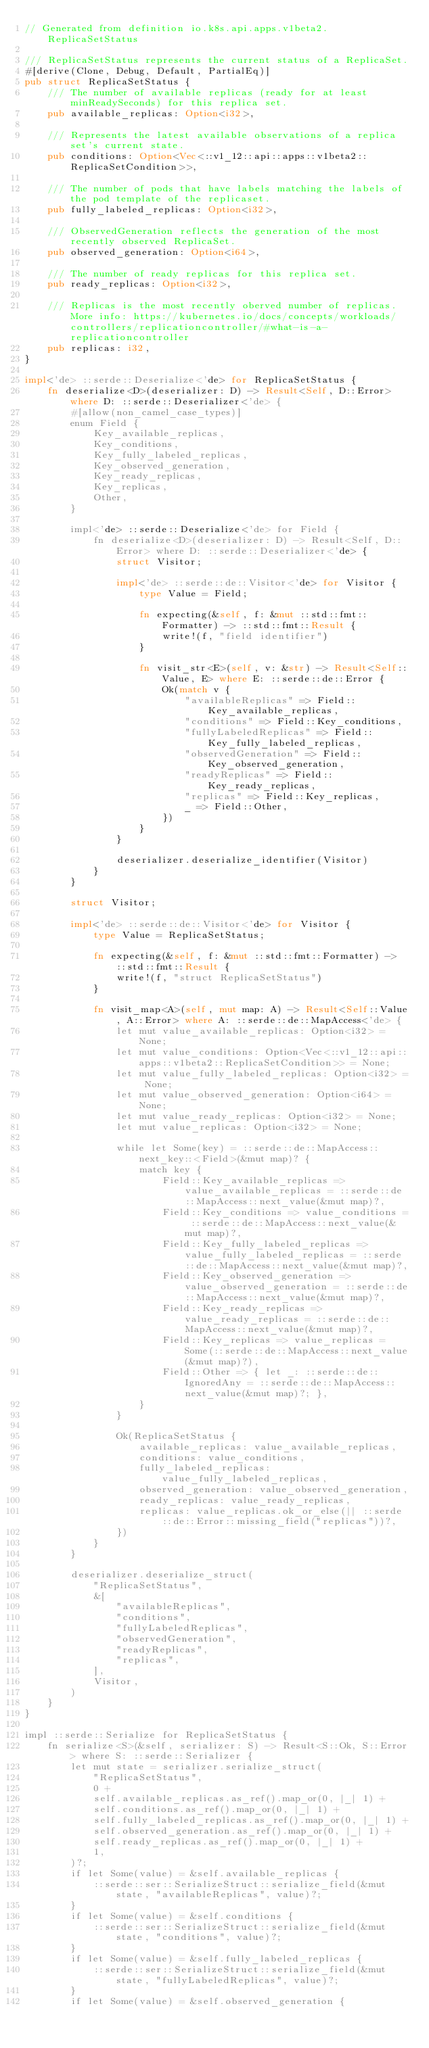Convert code to text. <code><loc_0><loc_0><loc_500><loc_500><_Rust_>// Generated from definition io.k8s.api.apps.v1beta2.ReplicaSetStatus

/// ReplicaSetStatus represents the current status of a ReplicaSet.
#[derive(Clone, Debug, Default, PartialEq)]
pub struct ReplicaSetStatus {
    /// The number of available replicas (ready for at least minReadySeconds) for this replica set.
    pub available_replicas: Option<i32>,

    /// Represents the latest available observations of a replica set's current state.
    pub conditions: Option<Vec<::v1_12::api::apps::v1beta2::ReplicaSetCondition>>,

    /// The number of pods that have labels matching the labels of the pod template of the replicaset.
    pub fully_labeled_replicas: Option<i32>,

    /// ObservedGeneration reflects the generation of the most recently observed ReplicaSet.
    pub observed_generation: Option<i64>,

    /// The number of ready replicas for this replica set.
    pub ready_replicas: Option<i32>,

    /// Replicas is the most recently oberved number of replicas. More info: https://kubernetes.io/docs/concepts/workloads/controllers/replicationcontroller/#what-is-a-replicationcontroller
    pub replicas: i32,
}

impl<'de> ::serde::Deserialize<'de> for ReplicaSetStatus {
    fn deserialize<D>(deserializer: D) -> Result<Self, D::Error> where D: ::serde::Deserializer<'de> {
        #[allow(non_camel_case_types)]
        enum Field {
            Key_available_replicas,
            Key_conditions,
            Key_fully_labeled_replicas,
            Key_observed_generation,
            Key_ready_replicas,
            Key_replicas,
            Other,
        }

        impl<'de> ::serde::Deserialize<'de> for Field {
            fn deserialize<D>(deserializer: D) -> Result<Self, D::Error> where D: ::serde::Deserializer<'de> {
                struct Visitor;

                impl<'de> ::serde::de::Visitor<'de> for Visitor {
                    type Value = Field;

                    fn expecting(&self, f: &mut ::std::fmt::Formatter) -> ::std::fmt::Result {
                        write!(f, "field identifier")
                    }

                    fn visit_str<E>(self, v: &str) -> Result<Self::Value, E> where E: ::serde::de::Error {
                        Ok(match v {
                            "availableReplicas" => Field::Key_available_replicas,
                            "conditions" => Field::Key_conditions,
                            "fullyLabeledReplicas" => Field::Key_fully_labeled_replicas,
                            "observedGeneration" => Field::Key_observed_generation,
                            "readyReplicas" => Field::Key_ready_replicas,
                            "replicas" => Field::Key_replicas,
                            _ => Field::Other,
                        })
                    }
                }

                deserializer.deserialize_identifier(Visitor)
            }
        }

        struct Visitor;

        impl<'de> ::serde::de::Visitor<'de> for Visitor {
            type Value = ReplicaSetStatus;

            fn expecting(&self, f: &mut ::std::fmt::Formatter) -> ::std::fmt::Result {
                write!(f, "struct ReplicaSetStatus")
            }

            fn visit_map<A>(self, mut map: A) -> Result<Self::Value, A::Error> where A: ::serde::de::MapAccess<'de> {
                let mut value_available_replicas: Option<i32> = None;
                let mut value_conditions: Option<Vec<::v1_12::api::apps::v1beta2::ReplicaSetCondition>> = None;
                let mut value_fully_labeled_replicas: Option<i32> = None;
                let mut value_observed_generation: Option<i64> = None;
                let mut value_ready_replicas: Option<i32> = None;
                let mut value_replicas: Option<i32> = None;

                while let Some(key) = ::serde::de::MapAccess::next_key::<Field>(&mut map)? {
                    match key {
                        Field::Key_available_replicas => value_available_replicas = ::serde::de::MapAccess::next_value(&mut map)?,
                        Field::Key_conditions => value_conditions = ::serde::de::MapAccess::next_value(&mut map)?,
                        Field::Key_fully_labeled_replicas => value_fully_labeled_replicas = ::serde::de::MapAccess::next_value(&mut map)?,
                        Field::Key_observed_generation => value_observed_generation = ::serde::de::MapAccess::next_value(&mut map)?,
                        Field::Key_ready_replicas => value_ready_replicas = ::serde::de::MapAccess::next_value(&mut map)?,
                        Field::Key_replicas => value_replicas = Some(::serde::de::MapAccess::next_value(&mut map)?),
                        Field::Other => { let _: ::serde::de::IgnoredAny = ::serde::de::MapAccess::next_value(&mut map)?; },
                    }
                }

                Ok(ReplicaSetStatus {
                    available_replicas: value_available_replicas,
                    conditions: value_conditions,
                    fully_labeled_replicas: value_fully_labeled_replicas,
                    observed_generation: value_observed_generation,
                    ready_replicas: value_ready_replicas,
                    replicas: value_replicas.ok_or_else(|| ::serde::de::Error::missing_field("replicas"))?,
                })
            }
        }

        deserializer.deserialize_struct(
            "ReplicaSetStatus",
            &[
                "availableReplicas",
                "conditions",
                "fullyLabeledReplicas",
                "observedGeneration",
                "readyReplicas",
                "replicas",
            ],
            Visitor,
        )
    }
}

impl ::serde::Serialize for ReplicaSetStatus {
    fn serialize<S>(&self, serializer: S) -> Result<S::Ok, S::Error> where S: ::serde::Serializer {
        let mut state = serializer.serialize_struct(
            "ReplicaSetStatus",
            0 +
            self.available_replicas.as_ref().map_or(0, |_| 1) +
            self.conditions.as_ref().map_or(0, |_| 1) +
            self.fully_labeled_replicas.as_ref().map_or(0, |_| 1) +
            self.observed_generation.as_ref().map_or(0, |_| 1) +
            self.ready_replicas.as_ref().map_or(0, |_| 1) +
            1,
        )?;
        if let Some(value) = &self.available_replicas {
            ::serde::ser::SerializeStruct::serialize_field(&mut state, "availableReplicas", value)?;
        }
        if let Some(value) = &self.conditions {
            ::serde::ser::SerializeStruct::serialize_field(&mut state, "conditions", value)?;
        }
        if let Some(value) = &self.fully_labeled_replicas {
            ::serde::ser::SerializeStruct::serialize_field(&mut state, "fullyLabeledReplicas", value)?;
        }
        if let Some(value) = &self.observed_generation {</code> 